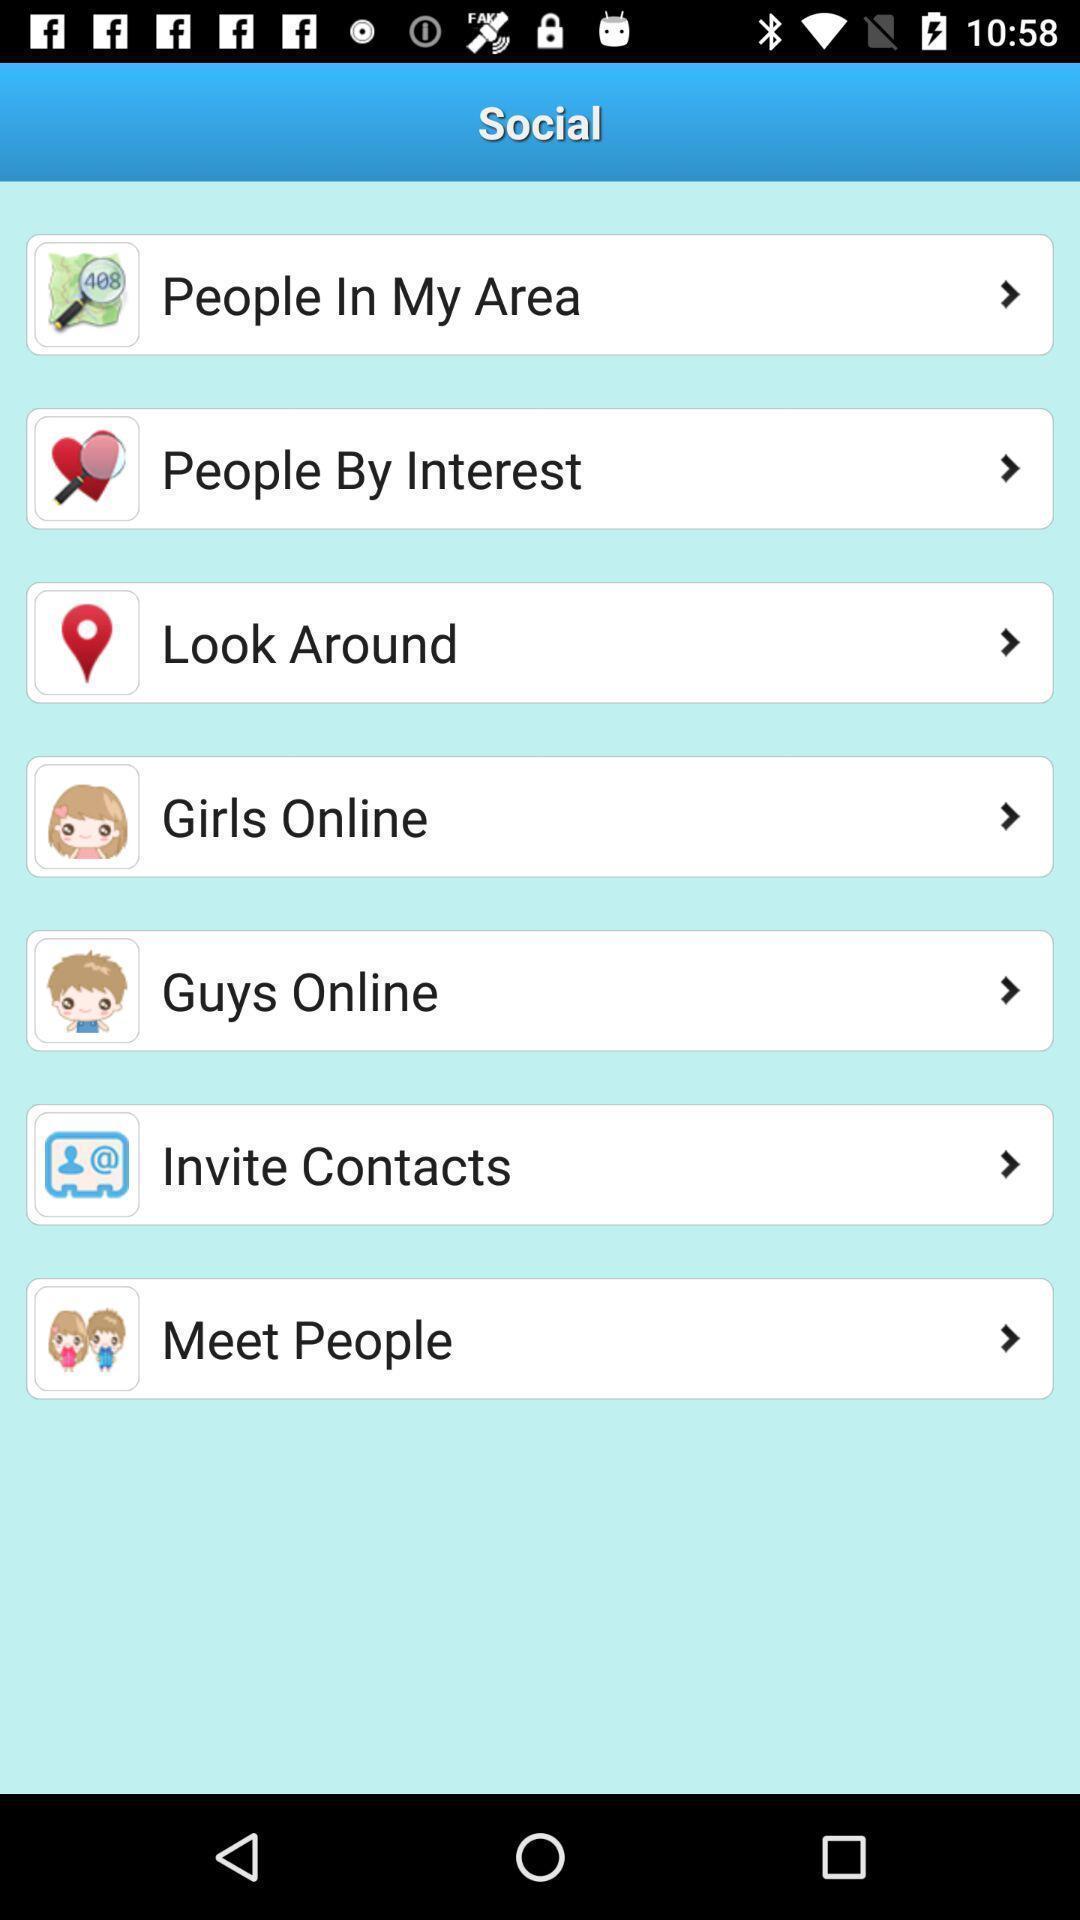Give me a summary of this screen capture. Screen displaying options. 